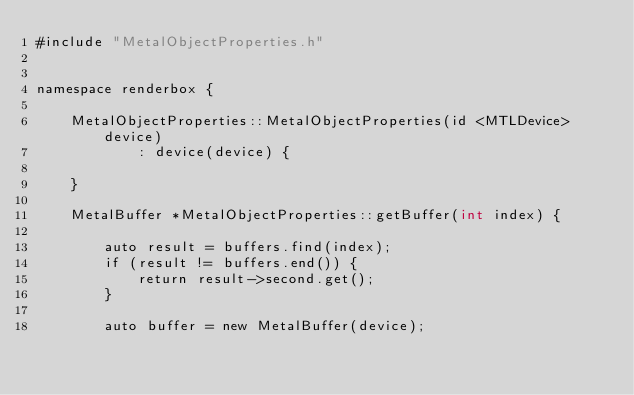<code> <loc_0><loc_0><loc_500><loc_500><_ObjectiveC_>#include "MetalObjectProperties.h"


namespace renderbox {

    MetalObjectProperties::MetalObjectProperties(id <MTLDevice> device)
            : device(device) {

    }

    MetalBuffer *MetalObjectProperties::getBuffer(int index) {

        auto result = buffers.find(index);
        if (result != buffers.end()) {
            return result->second.get();
        }

        auto buffer = new MetalBuffer(device);</code> 